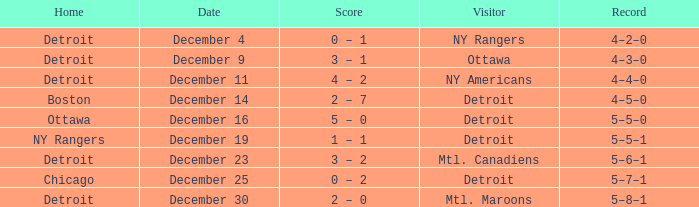What record has detroit as the home and mtl. maroons as the visitor? 5–8–1. 